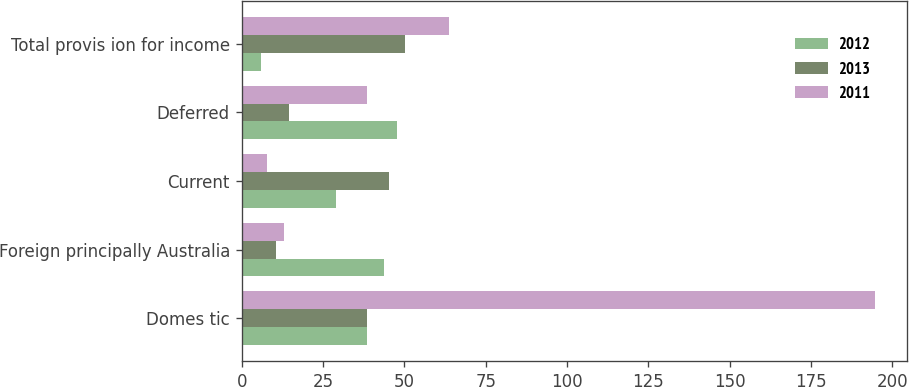Convert chart. <chart><loc_0><loc_0><loc_500><loc_500><stacked_bar_chart><ecel><fcel>Domes tic<fcel>Foreign principally Australia<fcel>Current<fcel>Deferred<fcel>Total provis ion for income<nl><fcel>2012<fcel>38.4<fcel>43.7<fcel>29<fcel>47.7<fcel>5.9<nl><fcel>2013<fcel>38.4<fcel>10.6<fcel>45.4<fcel>14.6<fcel>50.3<nl><fcel>2011<fcel>194.7<fcel>13.1<fcel>7.8<fcel>38.4<fcel>63.7<nl></chart> 